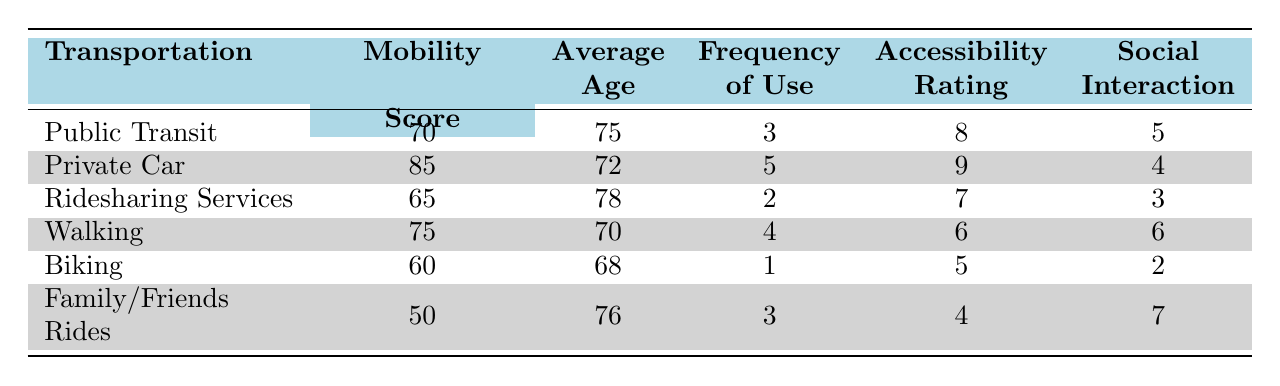What is the mobility independence score for Private Car? From the table, the row labeled "Private Car" shows a mobility independence score of 85.
Answer: 85 What transportation method has the lowest accessibility rating? Looking at the accessibility rating column, "Family/Friends Rides" has an accessibility rating of 4, which is the lowest compared to the other transportation methods.
Answer: Family/Friends Rides What is the average age of users for all transportation methods? To find the average age, we sum the average ages of all methods (75 + 72 + 78 + 70 + 68 + 76 = 439) and divide by the number of methods (6), resulting in an average age of 73.17, which can be rounded to 73.
Answer: 73 True or False: Walking has a higher mobility independence score than Ridesharing Services. The mobility independence score for Walking is 75, while for Ridesharing Services it is 65. Since 75 is greater than 65, the statement is true.
Answer: True What is the difference in the frequency of use per week between Public Transit and Biking? The frequency of use for Public Transit is 3 times a week, and for Biking, it is 1 time a week. The difference is calculated as 3 - 1 = 2.
Answer: 2 Which transportation method has the highest frequency of use? The frequency of use for each method is compared, and the row for "Private Car" shows a frequency of 5 times per week, which is the highest among all listed methods.
Answer: Private Car How many points higher is the mobility independence score of Private Car compared to Family/Friends Rides? The mobility independence score for Private Car is 85 and for Family/Friends Rides it is 50. The calculation is 85 - 50 = 35, indicating that Private Car is 35 points higher.
Answer: 35 Is the average age of Ridesharing Services users older than that of Walking? The average age for Ridesharing Services is 78, while for Walking, it is 70. Since 78 is greater than 70, the answer is yes.
Answer: Yes What is the overall average social interaction frequency for all transportation methods? Summing the social interaction frequencies (5 + 4 + 3 + 6 + 2 + 7 = 27) and dividing by 6 gives an overall average social interaction frequency of 4.5, which can be rounded to 5.
Answer: 5 